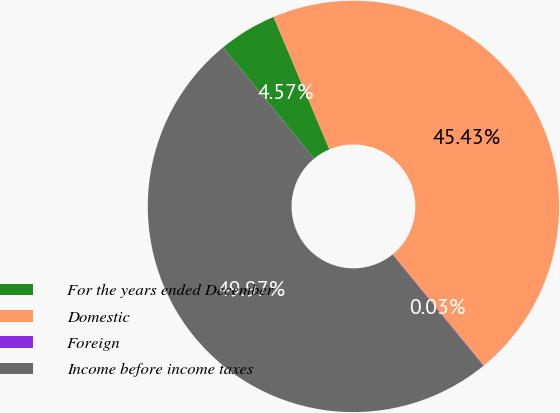<chart> <loc_0><loc_0><loc_500><loc_500><pie_chart><fcel>For the years ended December<fcel>Domestic<fcel>Foreign<fcel>Income before income taxes<nl><fcel>4.57%<fcel>45.43%<fcel>0.03%<fcel>49.97%<nl></chart> 